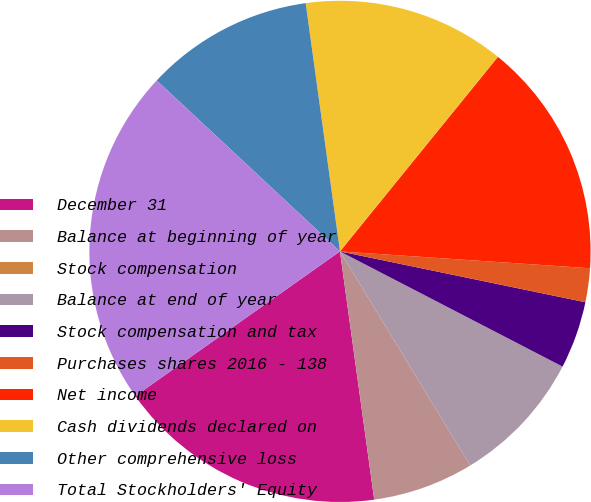Convert chart to OTSL. <chart><loc_0><loc_0><loc_500><loc_500><pie_chart><fcel>December 31<fcel>Balance at beginning of year<fcel>Stock compensation<fcel>Balance at end of year<fcel>Stock compensation and tax<fcel>Purchases shares 2016 - 138<fcel>Net income<fcel>Cash dividends declared on<fcel>Other comprehensive loss<fcel>Total Stockholders' Equity<nl><fcel>17.39%<fcel>6.52%<fcel>0.0%<fcel>8.7%<fcel>4.35%<fcel>2.18%<fcel>15.22%<fcel>13.04%<fcel>10.87%<fcel>21.74%<nl></chart> 